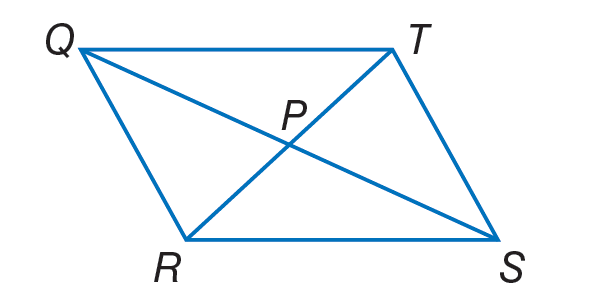Answer the mathemtical geometry problem and directly provide the correct option letter.
Question: If T P = 4 x + 2, Q P = 2 y - 6, P S = 5 y - 12, and P R = 6 x - 4, find x so that the quadrilateral is a parallelogram.
Choices: A: 0 B: 3 C: 5 D: 14 B 